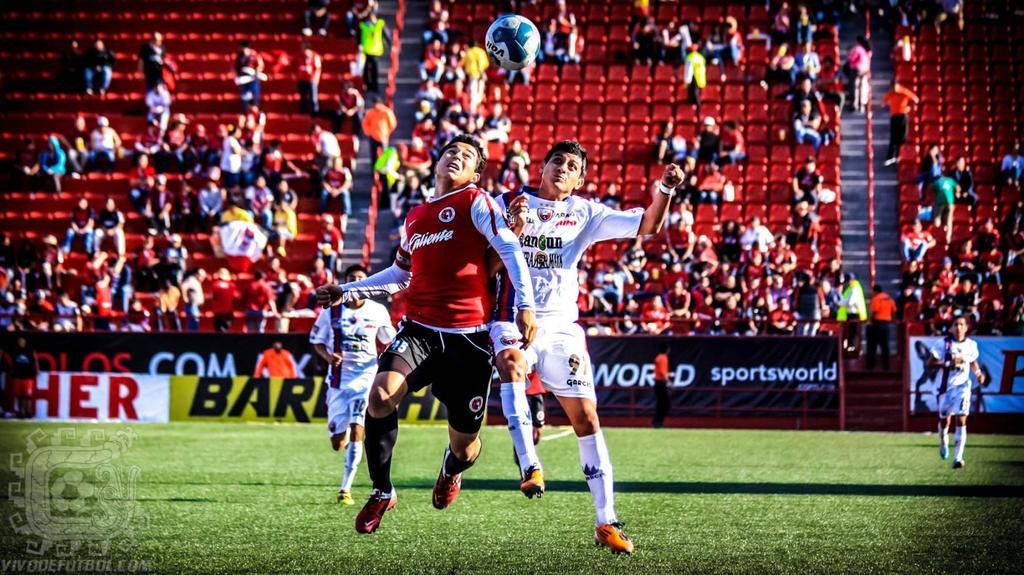<image>
Provide a brief description of the given image. a socer field with a player wearing a jersey that says 'caliente' on it 